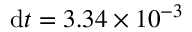<formula> <loc_0><loc_0><loc_500><loc_500>d t = 3 . 3 4 \times 1 0 ^ { - 3 }</formula> 